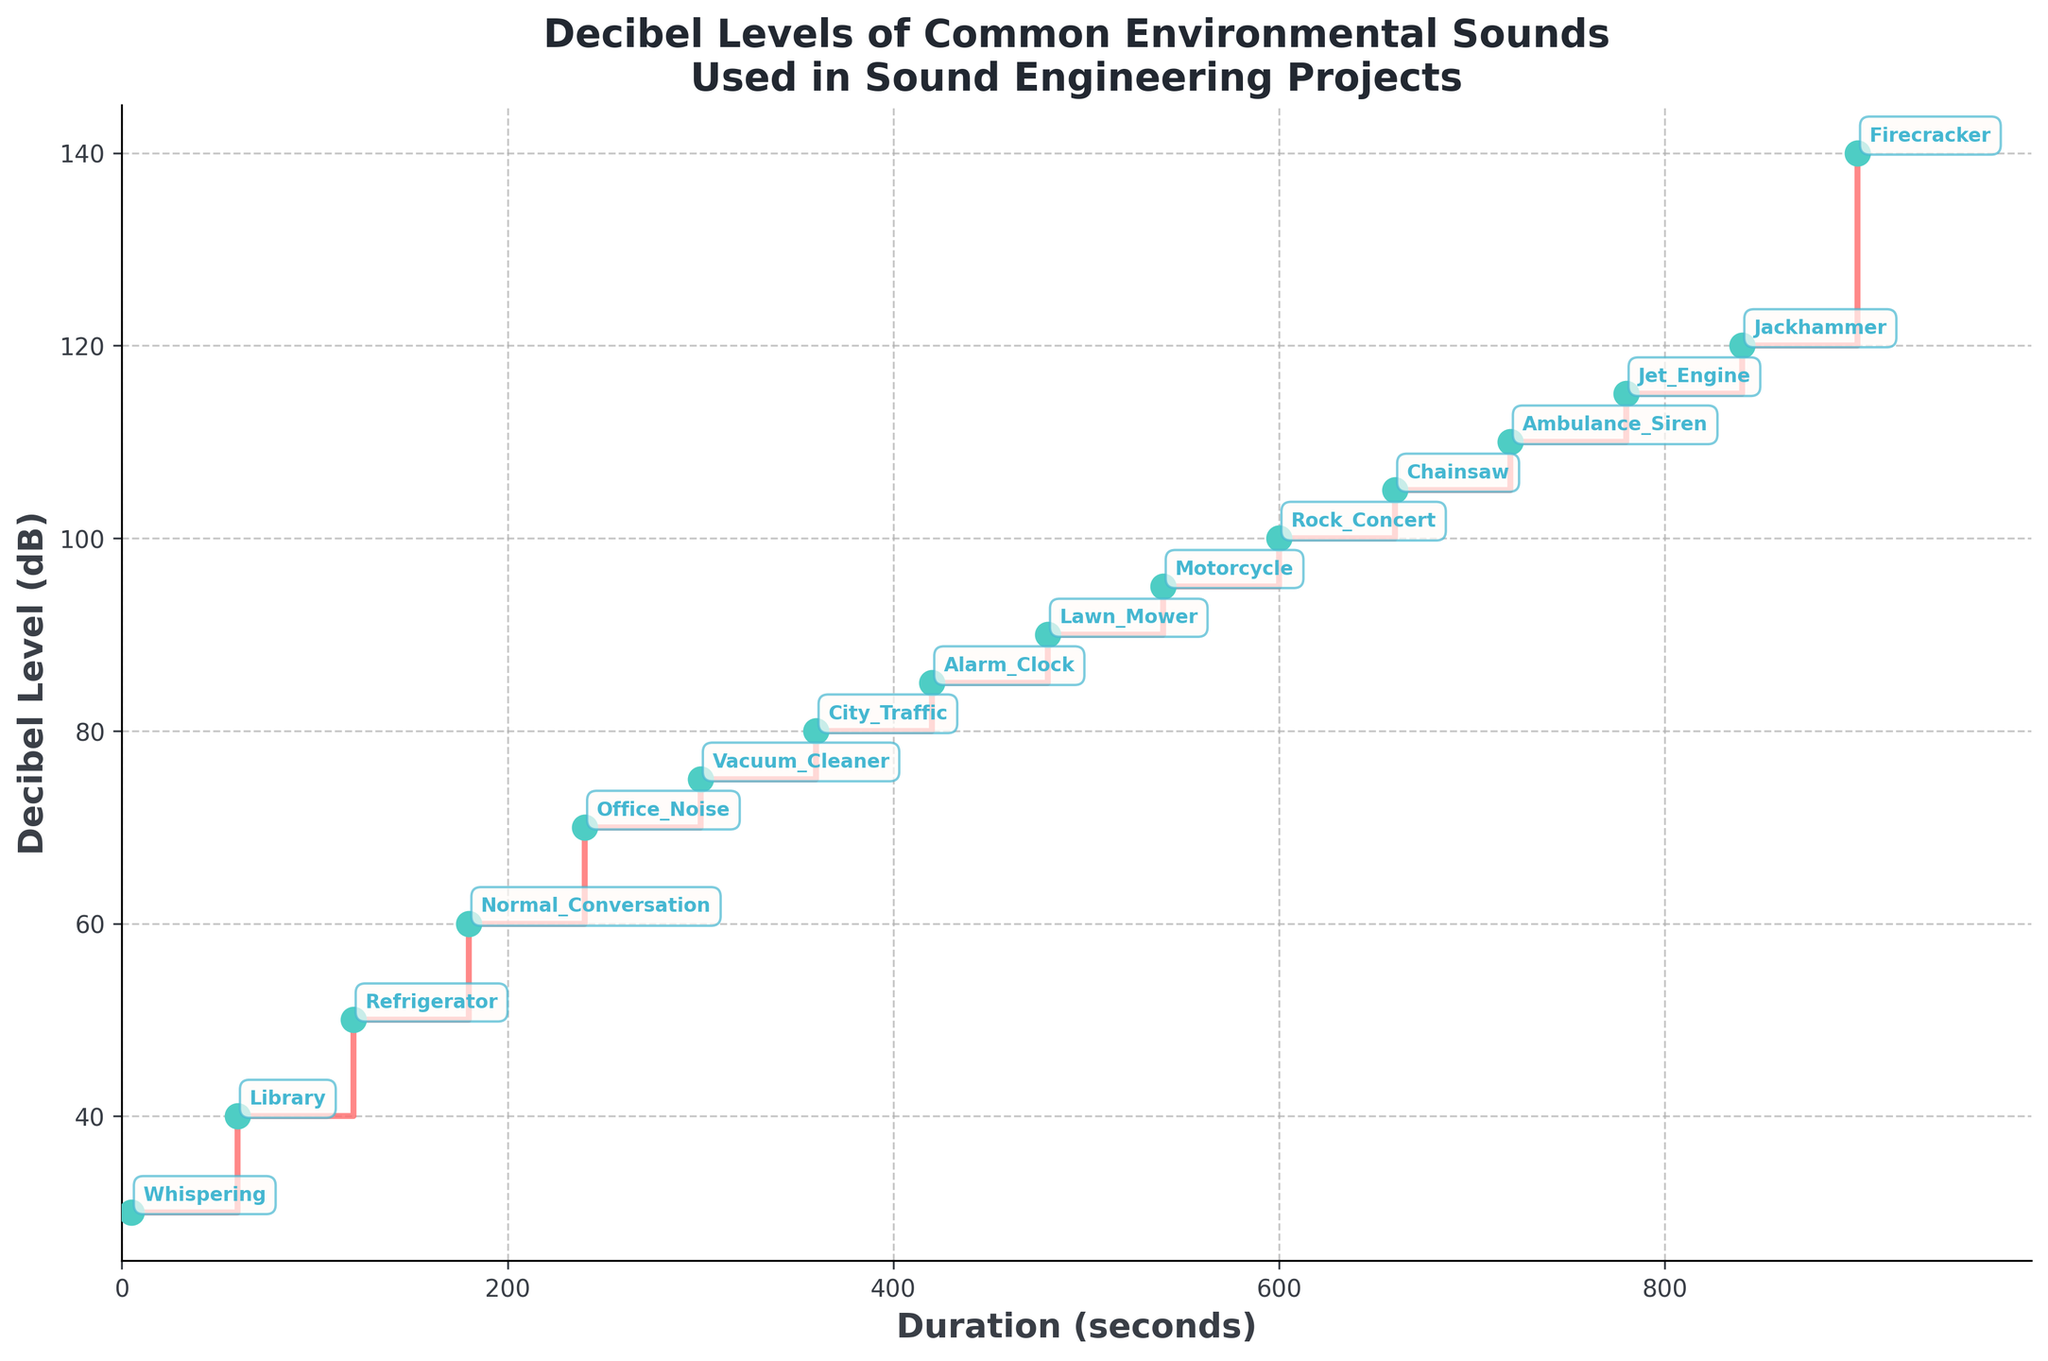What's the title of the figure? The title is displayed at the top of the figure and reads "Decibel Levels of Common Environmental Sounds Used in Sound Engineering Projects".
Answer: Decibel Levels of Common Environmental Sounds Used in Sound Engineering Projects What is the decibel level for a vacuum cleaner? Find the label "Vacuum_Cleaner" and look at the corresponding decibel level on the y-axis.
Answer: 75 Which sound has the longest duration, and what is its decibel level? The sound with the longest duration on the x-axis is "Firecracker", and its corresponding decibel level on the y-axis is 140 dB.
Answer: Firecracker, 140 dB How many data points are plotted in the figure? Count the number of labeled points in the figure; each represents a different sound. There are 16 labeled points in total.
Answer: 16 What is the decibel level difference between a Whispering and a Jet Engine? Find the decibel level for Whispering (30 dB) and Jet Engine (115 dB) and calculate the difference between them. 115 - 30 = 85 dB.
Answer: 85 dB Which sound has the highest decibel level, and what is its duration? The sound with the highest decibel level of 140 dB, indicated by the highest point on the y-axis, is "Firecracker", and its duration is 900 seconds.
Answer: Firecracker, 900 seconds What is the average decibel level of Office Noise and an Alarm Clock? Calculate the average of the decibel levels for Office Noise (70 dB) and Alarm Clock (85 dB). (70 + 85) / 2 = 77.5 dB.
Answer: 77.5 dB At what duration does the sound labeled "Chainsaw" occur, and what is its decibel level? The sound labeled "Chainsaw" is found at a duration of 660 seconds and has a decibel level of 105 dB.
Answer: 660 seconds, 105 dB Which is louder, a Motorcycle or a Rock Concert? Compare the decibel levels of a Motorcycle (95 dB) and a Rock Concert (100 dB). The Rock Concert is louder.
Answer: Rock Concert What is the range of decibel levels depicted in the figure? The lowest decibel level is Whispering at 30 dB, and the highest is Firecracker at 140 dB. The range is 140 - 30 = 110 dB.
Answer: 110 dB 